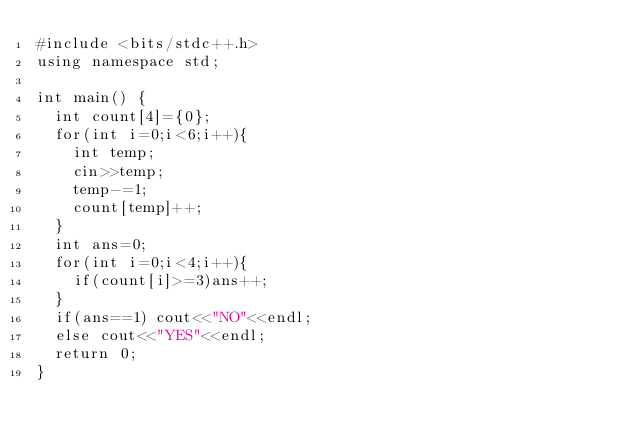<code> <loc_0><loc_0><loc_500><loc_500><_C++_>#include <bits/stdc++.h>
using namespace std;

int main() {
  int count[4]={0};
  for(int i=0;i<6;i++){
    int temp;
    cin>>temp;
    temp-=1;
    count[temp]++;
  }
  int ans=0;
  for(int i=0;i<4;i++){
    if(count[i]>=3)ans++;
  }
  if(ans==1) cout<<"NO"<<endl;
  else cout<<"YES"<<endl;
  return 0;
}
</code> 